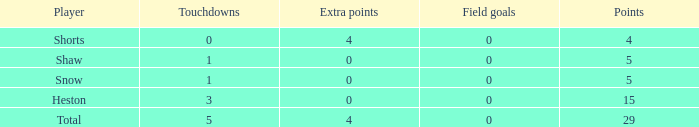What is the sum of all the touchdowns when the player had more than 0 extra points and less than 0 field goals? None. 